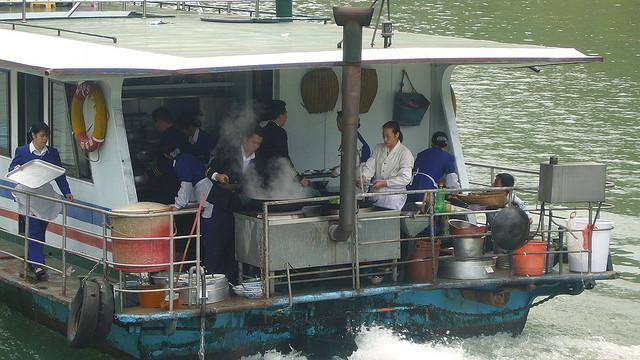How many ovens are there?
Give a very brief answer. 1. How many people are there?
Give a very brief answer. 5. How many of the train doors are green?
Give a very brief answer. 0. 